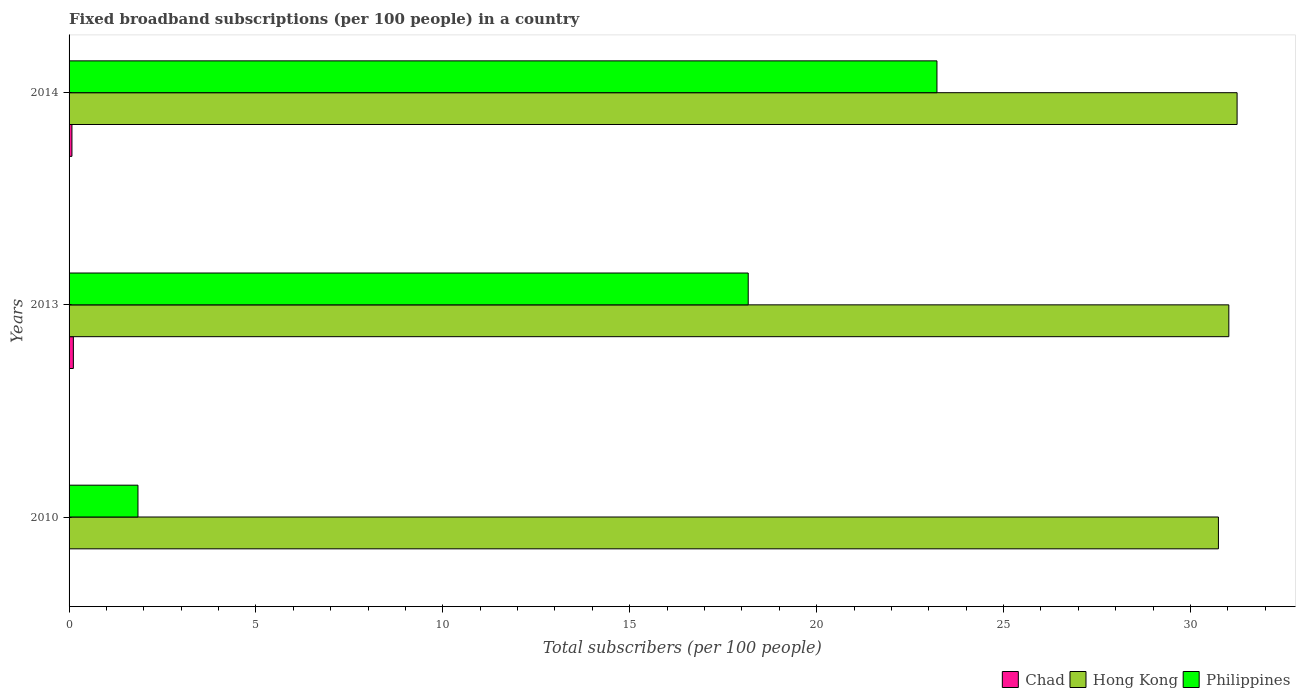How many groups of bars are there?
Provide a succinct answer. 3. Are the number of bars per tick equal to the number of legend labels?
Make the answer very short. Yes. How many bars are there on the 2nd tick from the bottom?
Give a very brief answer. 3. In how many cases, is the number of bars for a given year not equal to the number of legend labels?
Give a very brief answer. 0. What is the number of broadband subscriptions in Philippines in 2010?
Give a very brief answer. 1.84. Across all years, what is the maximum number of broadband subscriptions in Hong Kong?
Make the answer very short. 31.25. Across all years, what is the minimum number of broadband subscriptions in Chad?
Your answer should be compact. 0. In which year was the number of broadband subscriptions in Philippines maximum?
Your response must be concise. 2014. What is the total number of broadband subscriptions in Philippines in the graph?
Keep it short and to the point. 43.23. What is the difference between the number of broadband subscriptions in Hong Kong in 2010 and that in 2013?
Offer a terse response. -0.28. What is the difference between the number of broadband subscriptions in Hong Kong in 2010 and the number of broadband subscriptions in Chad in 2013?
Provide a short and direct response. 30.64. What is the average number of broadband subscriptions in Philippines per year?
Your response must be concise. 14.41. In the year 2013, what is the difference between the number of broadband subscriptions in Philippines and number of broadband subscriptions in Chad?
Ensure brevity in your answer.  18.06. What is the ratio of the number of broadband subscriptions in Chad in 2010 to that in 2013?
Make the answer very short. 0.02. Is the difference between the number of broadband subscriptions in Philippines in 2010 and 2014 greater than the difference between the number of broadband subscriptions in Chad in 2010 and 2014?
Make the answer very short. No. What is the difference between the highest and the second highest number of broadband subscriptions in Philippines?
Offer a very short reply. 5.05. What is the difference between the highest and the lowest number of broadband subscriptions in Philippines?
Provide a succinct answer. 21.38. In how many years, is the number of broadband subscriptions in Hong Kong greater than the average number of broadband subscriptions in Hong Kong taken over all years?
Ensure brevity in your answer.  2. Is the sum of the number of broadband subscriptions in Hong Kong in 2010 and 2014 greater than the maximum number of broadband subscriptions in Chad across all years?
Keep it short and to the point. Yes. What does the 3rd bar from the top in 2013 represents?
Provide a short and direct response. Chad. What does the 2nd bar from the bottom in 2014 represents?
Offer a terse response. Hong Kong. Is it the case that in every year, the sum of the number of broadband subscriptions in Philippines and number of broadband subscriptions in Chad is greater than the number of broadband subscriptions in Hong Kong?
Make the answer very short. No. How many years are there in the graph?
Your answer should be very brief. 3. Where does the legend appear in the graph?
Provide a succinct answer. Bottom right. How many legend labels are there?
Ensure brevity in your answer.  3. What is the title of the graph?
Give a very brief answer. Fixed broadband subscriptions (per 100 people) in a country. Does "Euro area" appear as one of the legend labels in the graph?
Provide a succinct answer. No. What is the label or title of the X-axis?
Give a very brief answer. Total subscribers (per 100 people). What is the Total subscribers (per 100 people) of Chad in 2010?
Offer a very short reply. 0. What is the Total subscribers (per 100 people) in Hong Kong in 2010?
Keep it short and to the point. 30.75. What is the Total subscribers (per 100 people) in Philippines in 2010?
Offer a terse response. 1.84. What is the Total subscribers (per 100 people) of Chad in 2013?
Make the answer very short. 0.11. What is the Total subscribers (per 100 people) in Hong Kong in 2013?
Your answer should be compact. 31.03. What is the Total subscribers (per 100 people) in Philippines in 2013?
Your response must be concise. 18.17. What is the Total subscribers (per 100 people) of Chad in 2014?
Your answer should be very brief. 0.08. What is the Total subscribers (per 100 people) in Hong Kong in 2014?
Provide a short and direct response. 31.25. What is the Total subscribers (per 100 people) of Philippines in 2014?
Give a very brief answer. 23.22. Across all years, what is the maximum Total subscribers (per 100 people) of Chad?
Ensure brevity in your answer.  0.11. Across all years, what is the maximum Total subscribers (per 100 people) in Hong Kong?
Ensure brevity in your answer.  31.25. Across all years, what is the maximum Total subscribers (per 100 people) in Philippines?
Give a very brief answer. 23.22. Across all years, what is the minimum Total subscribers (per 100 people) in Chad?
Provide a succinct answer. 0. Across all years, what is the minimum Total subscribers (per 100 people) of Hong Kong?
Give a very brief answer. 30.75. Across all years, what is the minimum Total subscribers (per 100 people) in Philippines?
Ensure brevity in your answer.  1.84. What is the total Total subscribers (per 100 people) in Chad in the graph?
Provide a succinct answer. 0.19. What is the total Total subscribers (per 100 people) of Hong Kong in the graph?
Give a very brief answer. 93.03. What is the total Total subscribers (per 100 people) of Philippines in the graph?
Make the answer very short. 43.23. What is the difference between the Total subscribers (per 100 people) in Chad in 2010 and that in 2013?
Ensure brevity in your answer.  -0.11. What is the difference between the Total subscribers (per 100 people) of Hong Kong in 2010 and that in 2013?
Your answer should be compact. -0.28. What is the difference between the Total subscribers (per 100 people) of Philippines in 2010 and that in 2013?
Make the answer very short. -16.33. What is the difference between the Total subscribers (per 100 people) in Chad in 2010 and that in 2014?
Your answer should be compact. -0.07. What is the difference between the Total subscribers (per 100 people) of Hong Kong in 2010 and that in 2014?
Make the answer very short. -0.5. What is the difference between the Total subscribers (per 100 people) of Philippines in 2010 and that in 2014?
Your answer should be very brief. -21.38. What is the difference between the Total subscribers (per 100 people) of Chad in 2013 and that in 2014?
Give a very brief answer. 0.04. What is the difference between the Total subscribers (per 100 people) of Hong Kong in 2013 and that in 2014?
Make the answer very short. -0.22. What is the difference between the Total subscribers (per 100 people) in Philippines in 2013 and that in 2014?
Provide a succinct answer. -5.05. What is the difference between the Total subscribers (per 100 people) of Chad in 2010 and the Total subscribers (per 100 people) of Hong Kong in 2013?
Provide a short and direct response. -31.03. What is the difference between the Total subscribers (per 100 people) of Chad in 2010 and the Total subscribers (per 100 people) of Philippines in 2013?
Your response must be concise. -18.17. What is the difference between the Total subscribers (per 100 people) of Hong Kong in 2010 and the Total subscribers (per 100 people) of Philippines in 2013?
Provide a short and direct response. 12.58. What is the difference between the Total subscribers (per 100 people) in Chad in 2010 and the Total subscribers (per 100 people) in Hong Kong in 2014?
Provide a succinct answer. -31.25. What is the difference between the Total subscribers (per 100 people) in Chad in 2010 and the Total subscribers (per 100 people) in Philippines in 2014?
Ensure brevity in your answer.  -23.22. What is the difference between the Total subscribers (per 100 people) of Hong Kong in 2010 and the Total subscribers (per 100 people) of Philippines in 2014?
Offer a very short reply. 7.53. What is the difference between the Total subscribers (per 100 people) in Chad in 2013 and the Total subscribers (per 100 people) in Hong Kong in 2014?
Offer a very short reply. -31.13. What is the difference between the Total subscribers (per 100 people) of Chad in 2013 and the Total subscribers (per 100 people) of Philippines in 2014?
Keep it short and to the point. -23.1. What is the difference between the Total subscribers (per 100 people) of Hong Kong in 2013 and the Total subscribers (per 100 people) of Philippines in 2014?
Make the answer very short. 7.81. What is the average Total subscribers (per 100 people) of Chad per year?
Provide a succinct answer. 0.06. What is the average Total subscribers (per 100 people) of Hong Kong per year?
Provide a short and direct response. 31.01. What is the average Total subscribers (per 100 people) in Philippines per year?
Provide a succinct answer. 14.41. In the year 2010, what is the difference between the Total subscribers (per 100 people) of Chad and Total subscribers (per 100 people) of Hong Kong?
Offer a very short reply. -30.75. In the year 2010, what is the difference between the Total subscribers (per 100 people) in Chad and Total subscribers (per 100 people) in Philippines?
Ensure brevity in your answer.  -1.84. In the year 2010, what is the difference between the Total subscribers (per 100 people) in Hong Kong and Total subscribers (per 100 people) in Philippines?
Your answer should be very brief. 28.91. In the year 2013, what is the difference between the Total subscribers (per 100 people) of Chad and Total subscribers (per 100 people) of Hong Kong?
Give a very brief answer. -30.91. In the year 2013, what is the difference between the Total subscribers (per 100 people) in Chad and Total subscribers (per 100 people) in Philippines?
Provide a succinct answer. -18.06. In the year 2013, what is the difference between the Total subscribers (per 100 people) of Hong Kong and Total subscribers (per 100 people) of Philippines?
Your answer should be compact. 12.86. In the year 2014, what is the difference between the Total subscribers (per 100 people) of Chad and Total subscribers (per 100 people) of Hong Kong?
Make the answer very short. -31.17. In the year 2014, what is the difference between the Total subscribers (per 100 people) of Chad and Total subscribers (per 100 people) of Philippines?
Give a very brief answer. -23.14. In the year 2014, what is the difference between the Total subscribers (per 100 people) in Hong Kong and Total subscribers (per 100 people) in Philippines?
Your response must be concise. 8.03. What is the ratio of the Total subscribers (per 100 people) of Chad in 2010 to that in 2013?
Offer a terse response. 0.02. What is the ratio of the Total subscribers (per 100 people) in Philippines in 2010 to that in 2013?
Keep it short and to the point. 0.1. What is the ratio of the Total subscribers (per 100 people) of Chad in 2010 to that in 2014?
Provide a succinct answer. 0.04. What is the ratio of the Total subscribers (per 100 people) in Hong Kong in 2010 to that in 2014?
Make the answer very short. 0.98. What is the ratio of the Total subscribers (per 100 people) of Philippines in 2010 to that in 2014?
Your answer should be very brief. 0.08. What is the ratio of the Total subscribers (per 100 people) of Chad in 2013 to that in 2014?
Ensure brevity in your answer.  1.49. What is the ratio of the Total subscribers (per 100 people) in Hong Kong in 2013 to that in 2014?
Your answer should be compact. 0.99. What is the ratio of the Total subscribers (per 100 people) in Philippines in 2013 to that in 2014?
Your answer should be compact. 0.78. What is the difference between the highest and the second highest Total subscribers (per 100 people) of Chad?
Offer a terse response. 0.04. What is the difference between the highest and the second highest Total subscribers (per 100 people) of Hong Kong?
Offer a very short reply. 0.22. What is the difference between the highest and the second highest Total subscribers (per 100 people) in Philippines?
Keep it short and to the point. 5.05. What is the difference between the highest and the lowest Total subscribers (per 100 people) of Chad?
Offer a very short reply. 0.11. What is the difference between the highest and the lowest Total subscribers (per 100 people) in Hong Kong?
Make the answer very short. 0.5. What is the difference between the highest and the lowest Total subscribers (per 100 people) of Philippines?
Your answer should be compact. 21.38. 